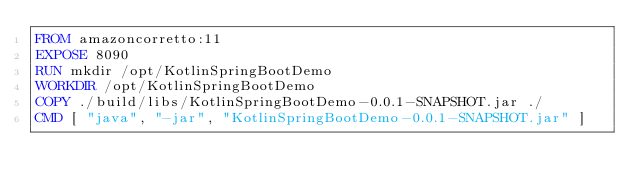<code> <loc_0><loc_0><loc_500><loc_500><_Dockerfile_>FROM amazoncorretto:11
EXPOSE 8090
RUN mkdir /opt/KotlinSpringBootDemo
WORKDIR /opt/KotlinSpringBootDemo
COPY ./build/libs/KotlinSpringBootDemo-0.0.1-SNAPSHOT.jar ./
CMD [ "java", "-jar", "KotlinSpringBootDemo-0.0.1-SNAPSHOT.jar" ]</code> 